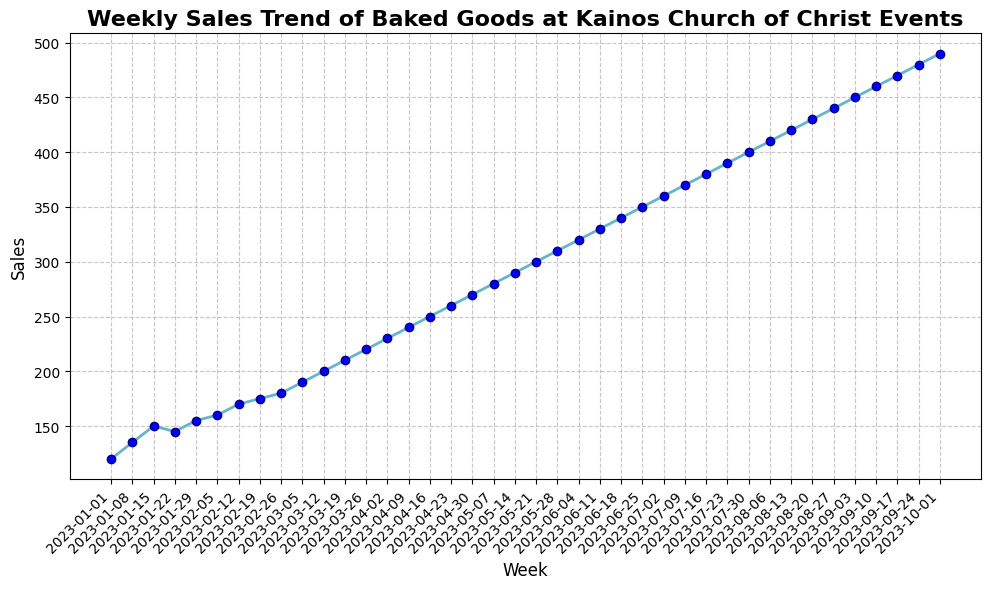What is the general trend of weekly sales from January to October? The line chart shows a consistent upward trend in sales from January to October. The line moves steadily upward without significant drops, indicating that sales are generally increasing week by week.
Answer: Increasing During which week did sales first reach 200 units? Sales reached 200 units during the week of March 12. By looking at the chart, the data point representing 200 units aligns with this week.
Answer: March 12 What is the difference in sales between the first week of January and the last week of September? Sales in the first week of January were 120 units, and sales in the last week of September were 480 units. The difference can be calculated as 480 - 120 = 360 units.
Answer: 360 Identify the week with the smallest increase in sales compared to the previous week. To determine this, we look at the data points and find the week-to-week increases. The smallest increase occurs between January 22 and January 29, where sales increased by only 10 units from 145 to 155.
Answer: January 29 What is the average weekly sales for the months of June and July combined? First, find the sales for each week in June and July: June (320, 330, 340, 350) and July (360, 370, 380, 390). Sum these values to get 320 + 330 + 340 + 350 + 360 + 370 + 380 + 390 = 2840. There are 8 weeks, so the average is 2840 / 8 = 355.
Answer: 355 By how much did sales increase from February 26 to March 5? Sales on February 26 were 180 units, and sales on March 5 were 190 units. The increase is calculated as 190 - 180 = 10 units.
Answer: 10 Is there any week where the sales remained the same as the previous week? By analyzing the line chart, we see that each data point is higher than the previous one, indicating that sales increased every week without remaining the same.
Answer: No What is the total sales from January to March? Sum the sales for all the weeks from January to March: Jan (120 + 135 + 150 + 145 + 155), Feb (160 + 170 + 175 + 180), Mar (190 + 200 + 210 + 220). Total is 120 + 135 + 150 + 145 + 155 + 160 + 170 + 175 + 180 + 190 + 200 + 210 + 220 = 2210.
Answer: 2210 How much did the sales increase from the first week to the last week in the dataset? The sales in the first week (January 1) were 120 units, and the sales in the last week (October 1) were 490 units. The increase can be calculated as 490 - 120 = 370 units.
Answer: 370 Which month saw the highest average weekly sales, and what was the average? To find this, calculate the average weekly sales for each month and compare them. August has the highest average: (410 + 420 + 430 + 440) / 4 = 425.
Answer: August, 425 